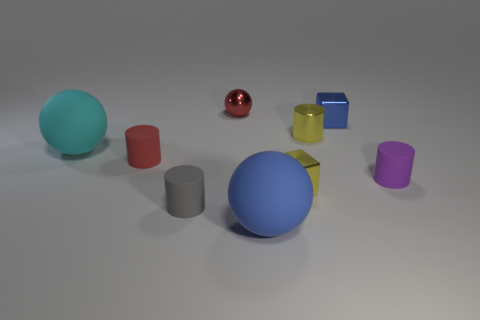Subtract all purple cylinders. How many cylinders are left? 3 Subtract 2 cylinders. How many cylinders are left? 2 Subtract all big matte spheres. How many spheres are left? 1 Add 1 cubes. How many objects exist? 10 Subtract all brown cylinders. Subtract all brown cubes. How many cylinders are left? 4 Subtract all cylinders. How many objects are left? 5 Add 8 shiny blocks. How many shiny blocks are left? 10 Add 6 cyan rubber objects. How many cyan rubber objects exist? 7 Subtract 1 blue blocks. How many objects are left? 8 Subtract all yellow metallic cylinders. Subtract all yellow cylinders. How many objects are left? 7 